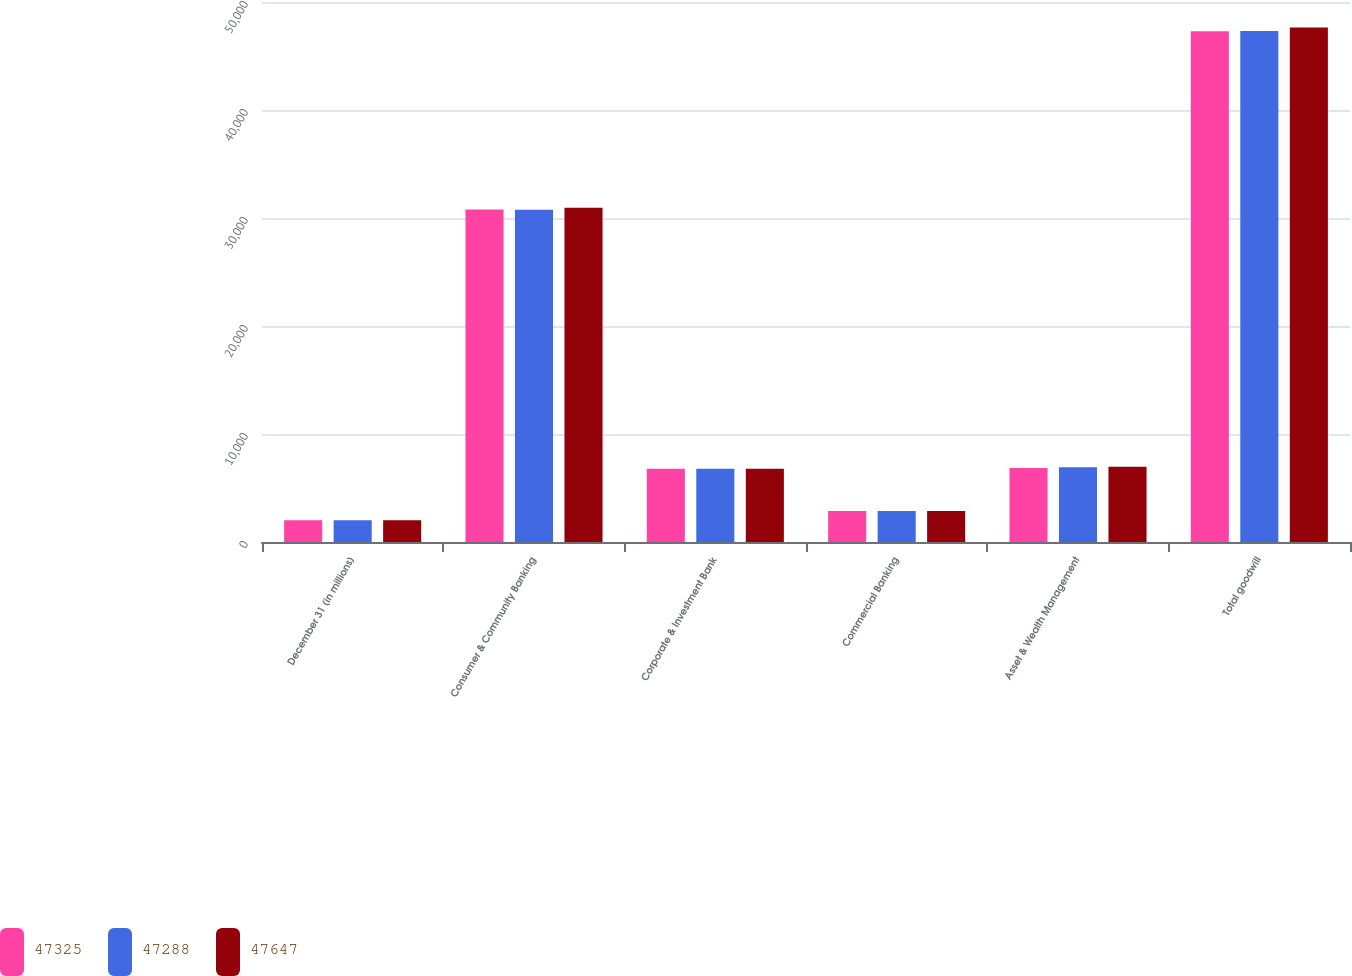Convert chart to OTSL. <chart><loc_0><loc_0><loc_500><loc_500><stacked_bar_chart><ecel><fcel>December 31 (in millions)<fcel>Consumer & Community Banking<fcel>Corporate & Investment Bank<fcel>Commercial Banking<fcel>Asset & Wealth Management<fcel>Total goodwill<nl><fcel>47325<fcel>2016<fcel>30797<fcel>6772<fcel>2861<fcel>6858<fcel>47288<nl><fcel>47288<fcel>2015<fcel>30769<fcel>6772<fcel>2861<fcel>6923<fcel>47325<nl><fcel>47647<fcel>2014<fcel>30941<fcel>6780<fcel>2861<fcel>6964<fcel>47647<nl></chart> 